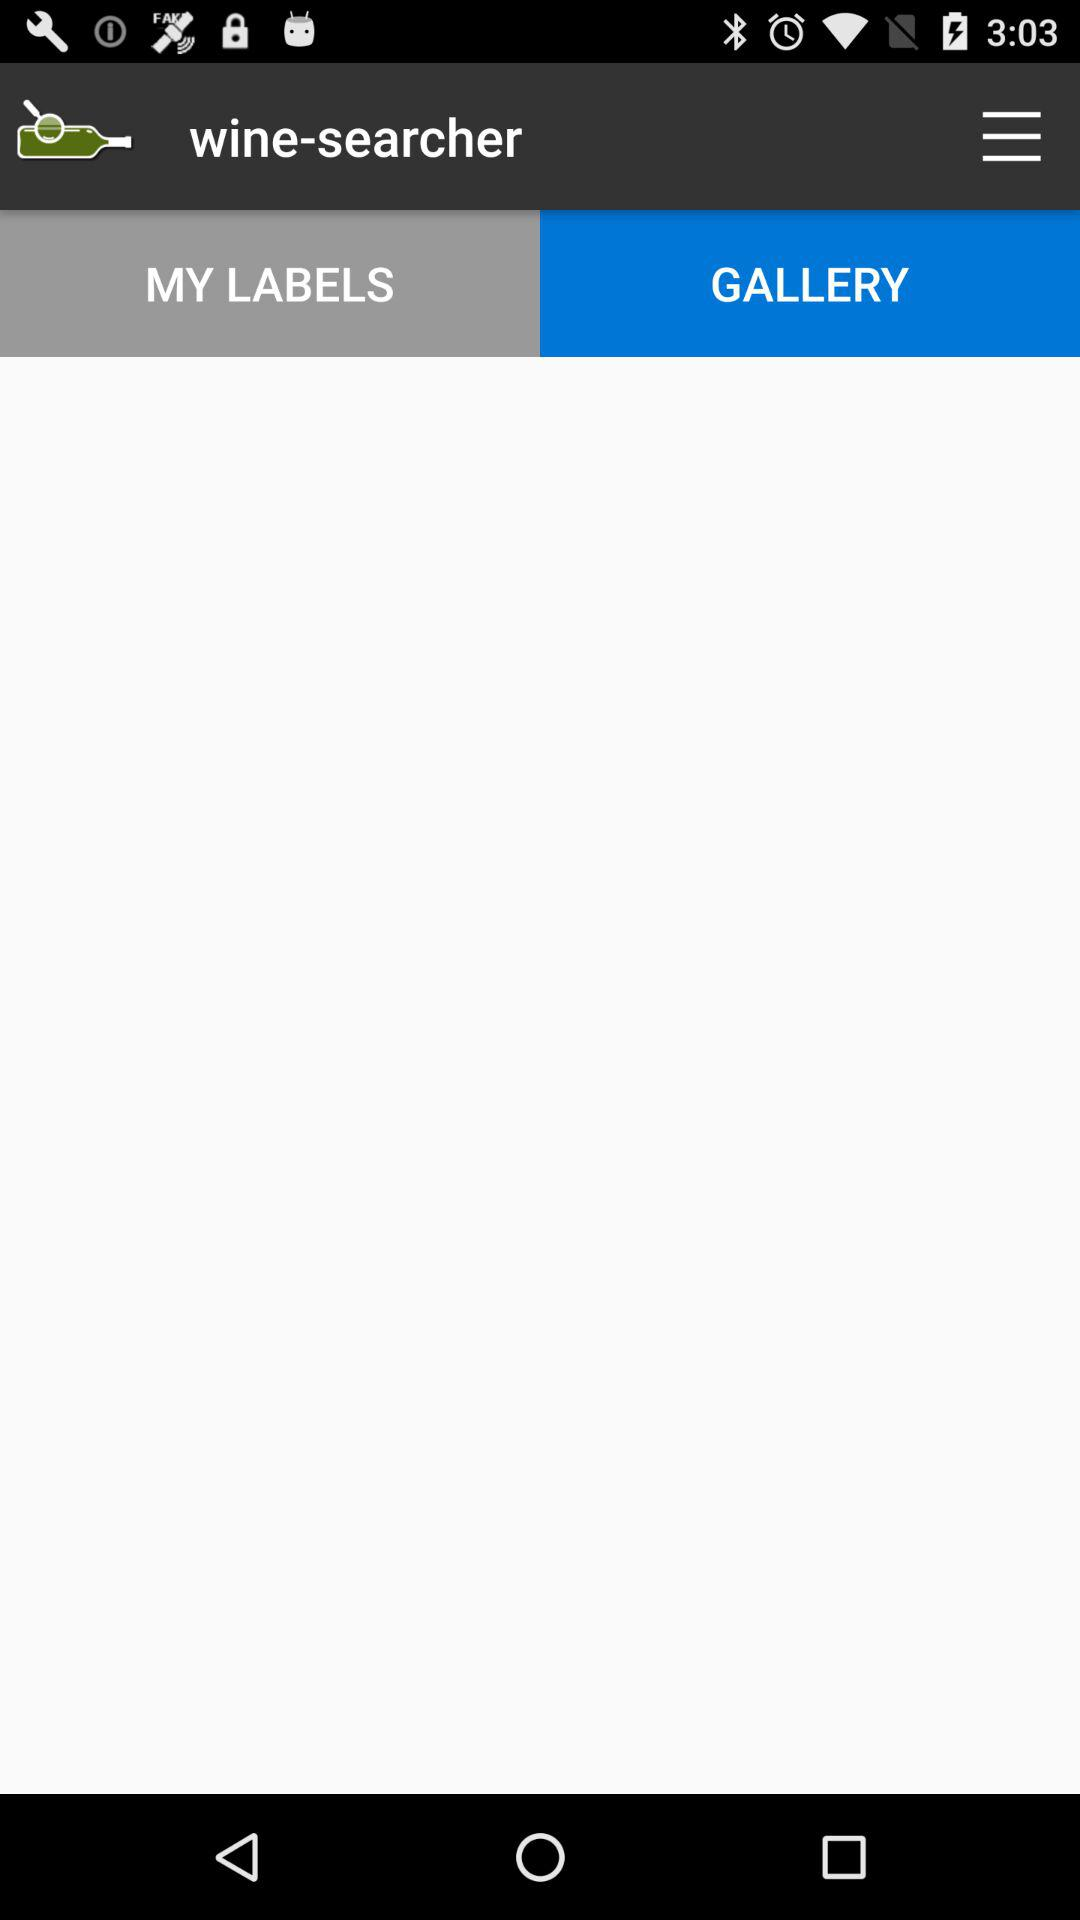Which tab is selected? The selected tab is "GALLERY". 